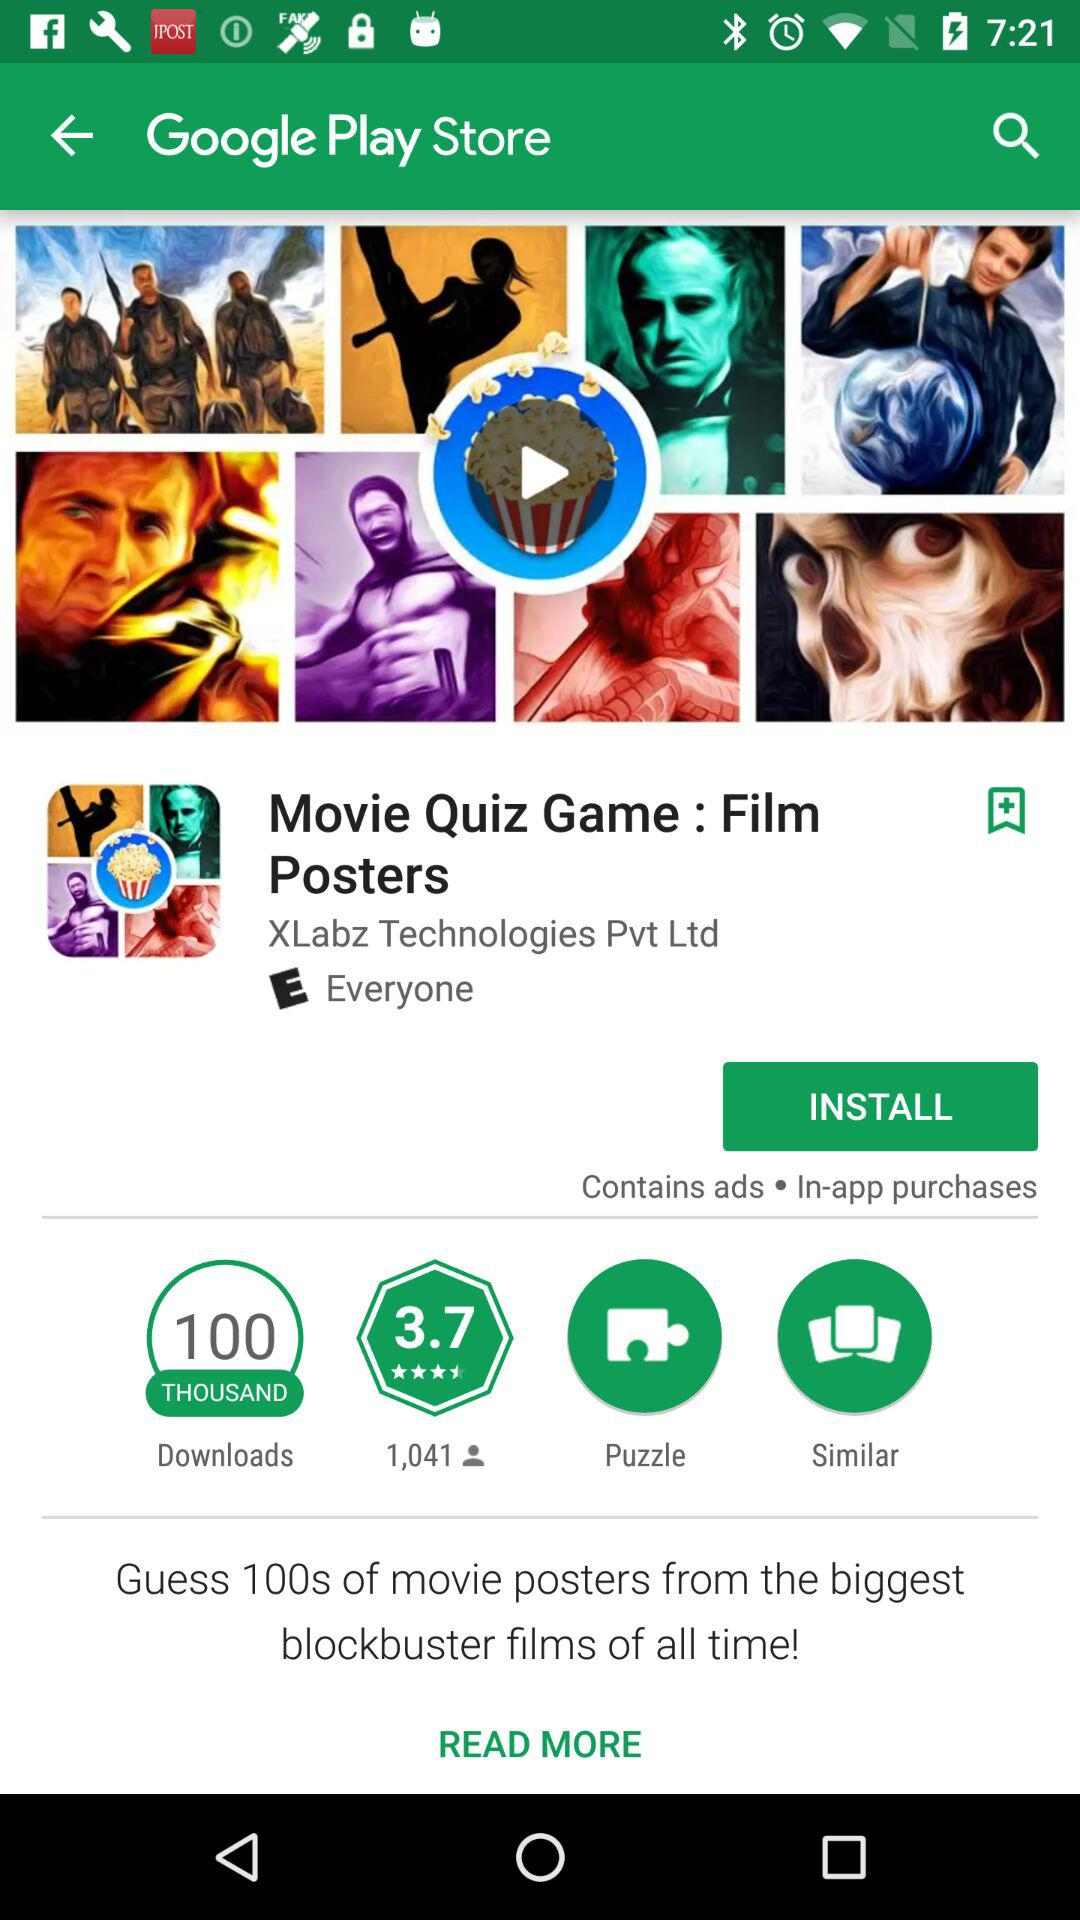How many people have downloaded the "Movie Quiz Game : Film Posters" application? The "Movie Quiz Game : Film Posters" application has been downloaded by 100 thousand people. 